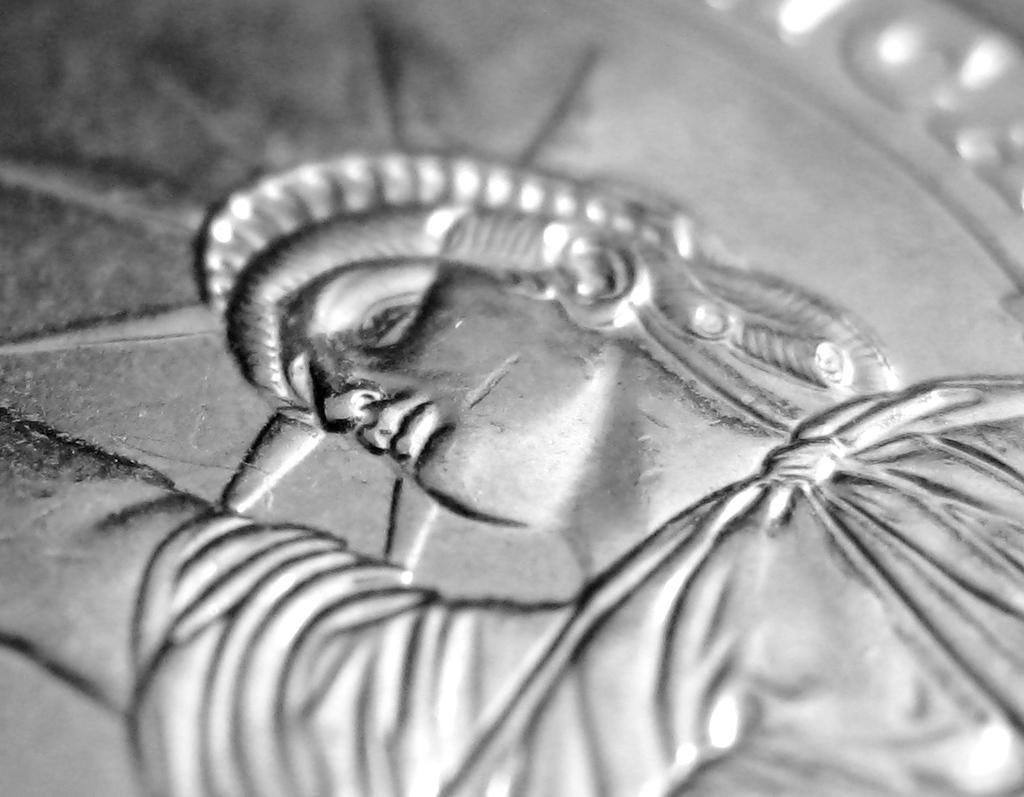Can you describe this image briefly? In this image we can see a statue of liberty on a metal object. 